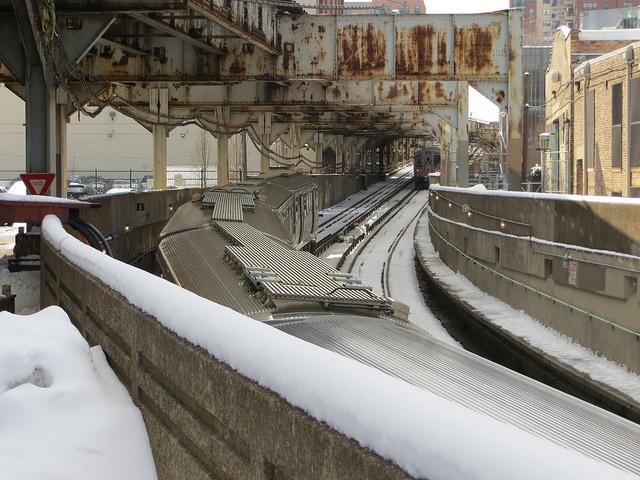What kind of scene is this?
Answer briefly. Train. How many trains are there?
Short answer required. 1. What does the sign on the far left indicate?
Quick response, please. Yield. 